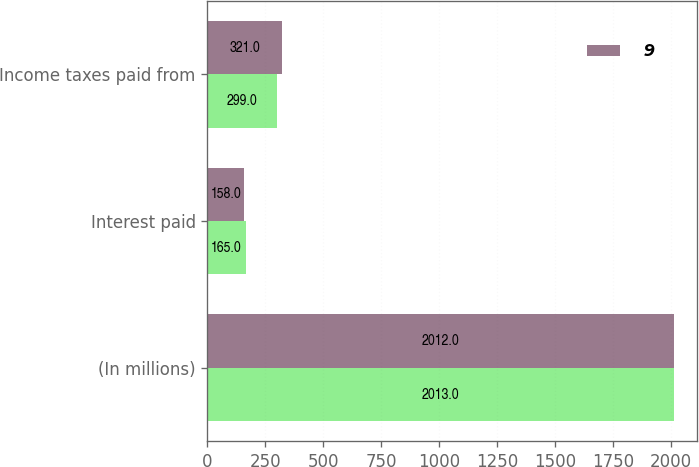<chart> <loc_0><loc_0><loc_500><loc_500><stacked_bar_chart><ecel><fcel>(In millions)<fcel>Interest paid<fcel>Income taxes paid from<nl><fcel>nan<fcel>2013<fcel>165<fcel>299<nl><fcel>9<fcel>2012<fcel>158<fcel>321<nl></chart> 